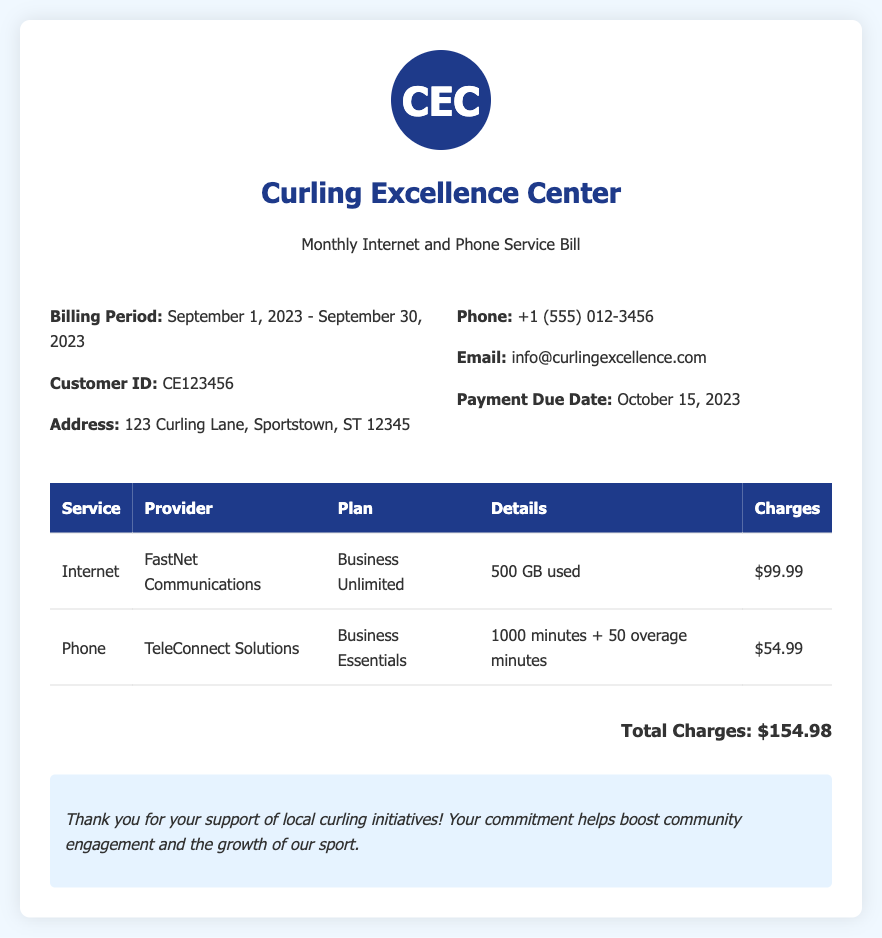What is the billing period? The billing period is specified in the document as the time frame for which the charges apply.
Answer: September 1, 2023 - September 30, 2023 What is the customer ID? The customer ID is a unique identifier for the account, found in the bill.
Answer: CE123456 What is the total charges on the bill? The total charges represent the sum of all service charges listed in the table.
Answer: $154.98 Who is the internet service provider? The document states the specific company providing the internet service.
Answer: FastNet Communications How many minutes are included in the phone plan? The phone plan details the number of minutes that are included before any overages apply.
Answer: 1000 minutes What was the internet usage in GB? The usage details indicate how much data was consumed during the billing period.
Answer: 500 GB used What is the due date for payment? The payment due date is specified and indicates when payment must be received.
Answer: October 15, 2023 What is the name of the document? The title of the document provides a clear identification of its content.
Answer: Monthly Internet and Phone Service Bill What additional message is included in the notes section? The notes section contains a thank-you message related to local initiatives.
Answer: Thank you for your support of local curling initiatives! 